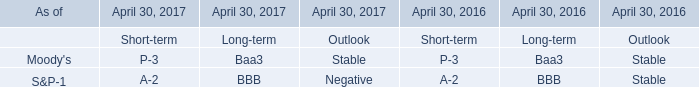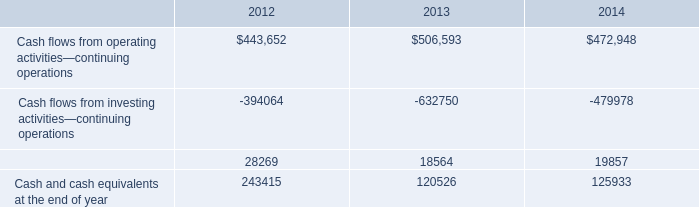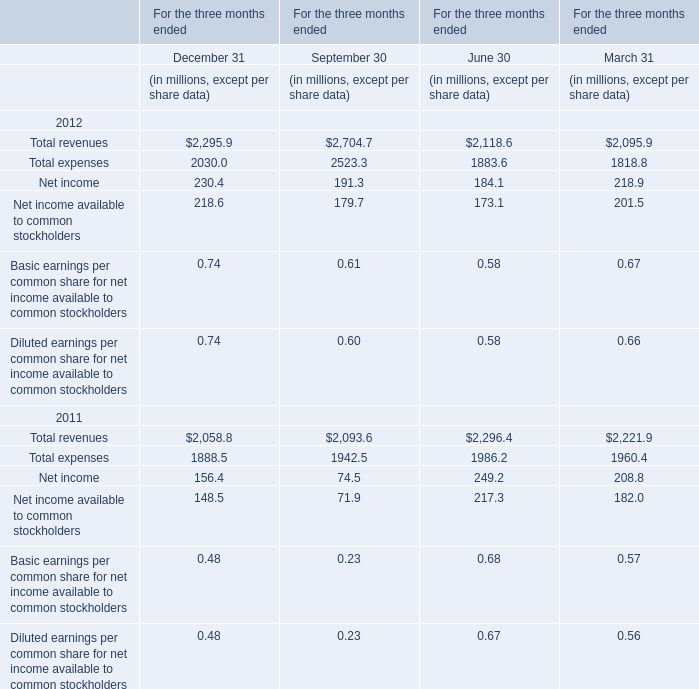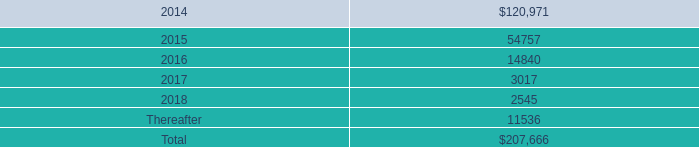What's the average of Total revenues in 2012 for For the three months ended? 
Computations: ((((2295.9 + 2704.7) + 2118.6) + 2095.9) / 4)
Answer: 2303.775. 